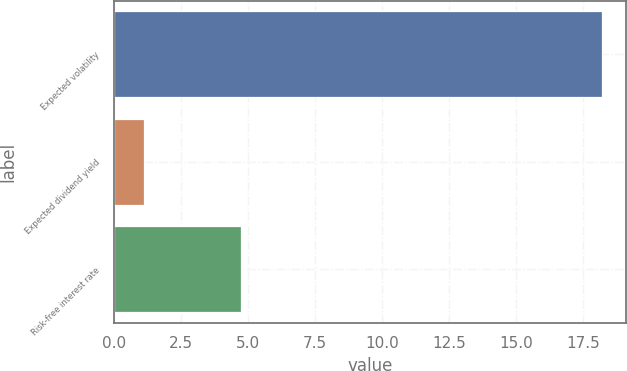Convert chart. <chart><loc_0><loc_0><loc_500><loc_500><bar_chart><fcel>Expected volatility<fcel>Expected dividend yield<fcel>Risk-free interest rate<nl><fcel>18.21<fcel>1.1<fcel>4.74<nl></chart> 